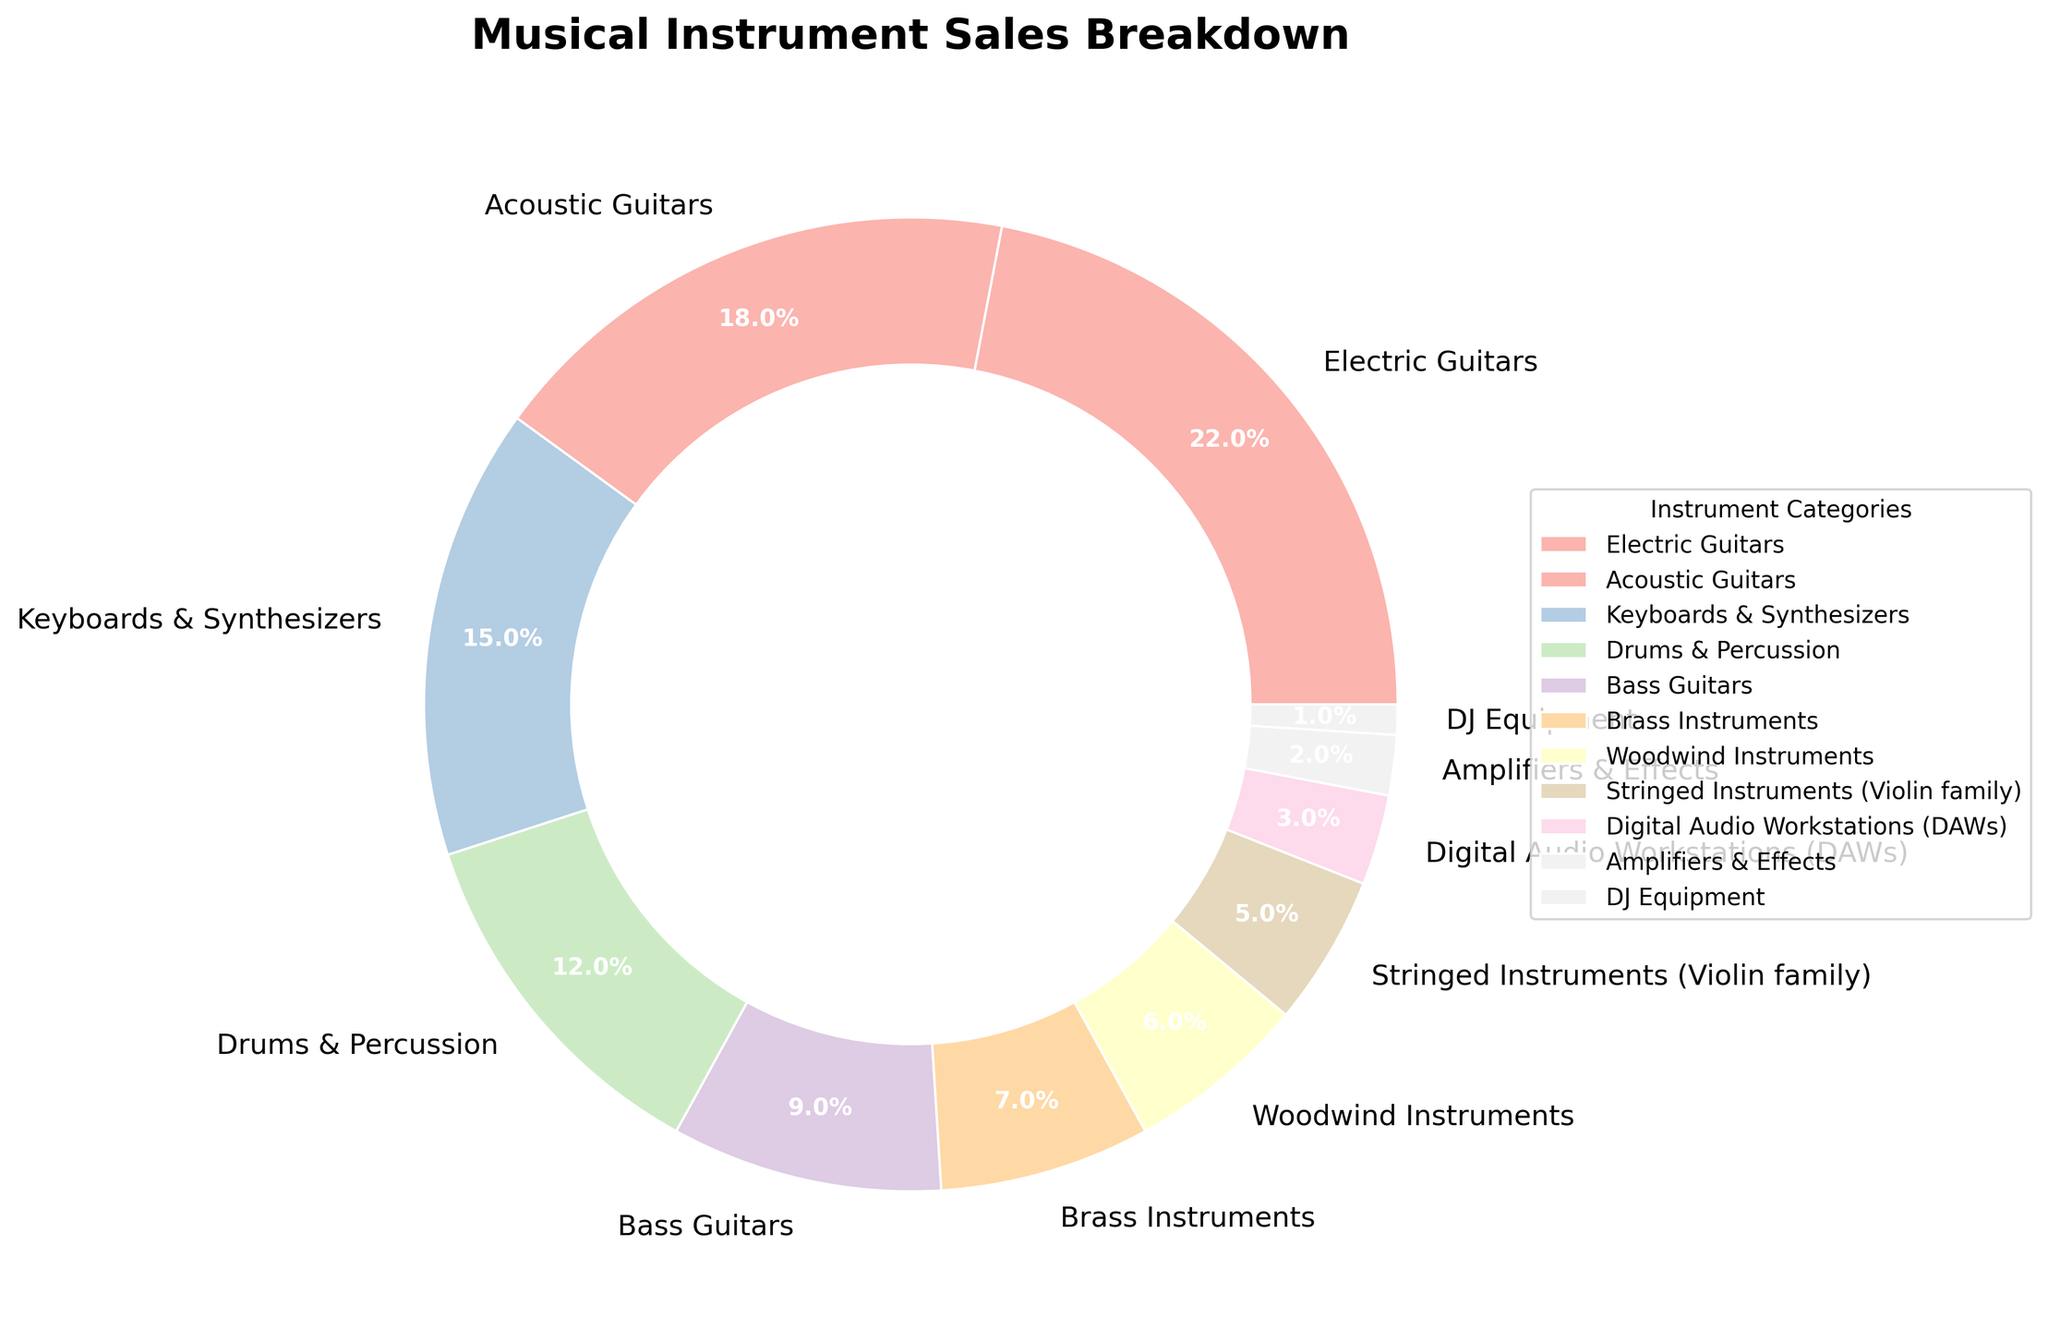What percentage of sales are attributed to guitars (both electric and acoustic)? First, identify the percentages for Electric Guitars (22%) and Acoustic Guitars (18%). Then, sum these percentages: 22% + 18% = 40%.
Answer: 40% Which instrument category contributes the least to total sales? Examine the pie chart to find the smallest segment. DJ Equipment has the smallest percentage at 1%.
Answer: DJ Equipment How much more than DAWs do Drums & Percussion contribute to sales? Compare the percentages: Drums & Percussion (12%) and Digital Audio Workstations (DAWs) (3%). Subtract the DAWs percentage from Drums & Percussion: 12% - 3% = 9%.
Answer: 9% What is the combined percentage of sales for Brass Instruments and Woodwind Instruments? Sum the percentages of Brass Instruments (7%) and Woodwind Instruments (6%). 7% + 6% = 13%.
Answer: 13% How does the sales percentage of Bass Guitars compare to Stringed Instruments (Violin family)? Look at the pie chart: Bass Guitars have 9% and Stringed Instruments (Violin family) have 5%. 9% is greater than 5%.
Answer: Bass Guitars have a higher percentage What is the sales percentage range (difference between the highest and lowest percentages) for the instrument categories? Identify the highest percentage (Electric Guitars at 22%) and the lowest percentage (DJ Equipment at 1%). Subtract the lowest percentage from the highest percentage: 22% - 1% = 21%.
Answer: 21% Which two instrument categories, when combined, account for exactly 33% of sales? Check combinations of various categories. Keyboards & Synthesizers contribute 15%, combined with Drums & Percussion at 12% equals 27%, and combining this with another category yields close results. Finally, Acoustic Guitars (18%) combined with Drums & Percussion (12%) do not work. Next is Electric Guitars (22%) and Keyboards & Synthesizers (15%) give 37%. Try Acoustic (18%) and Keyboards (15%) yield target result 33%.
Answer: Acoustic Guitars and Keyboards & Synthesizers What is the total percentage of sales for instruments related to electronic music production (Keyboards & Synthesizers and Digital Audio Workstations)? Sum the percentages of Keyboards & Synthesizers (15%) and Digital Audio Workstations (3%). 15% + 3% = 18%.
Answer: 18% If the sales of Amplifiers & Effects were to double, what would their new percentage be? The current percentage for Amplifiers & Effects is 2%. Doubling this percentage: 2% * 2 = 4%.
Answer: 4% What fraction of total sales is accounted for by DJ Equipment and Digital Audio Workstations together? Combine the percentages of DJ Equipment (1%) and Digital Audio Workstations (3%). Sum them to get 4%. The fraction is thus 4%.
Answer: 4% 